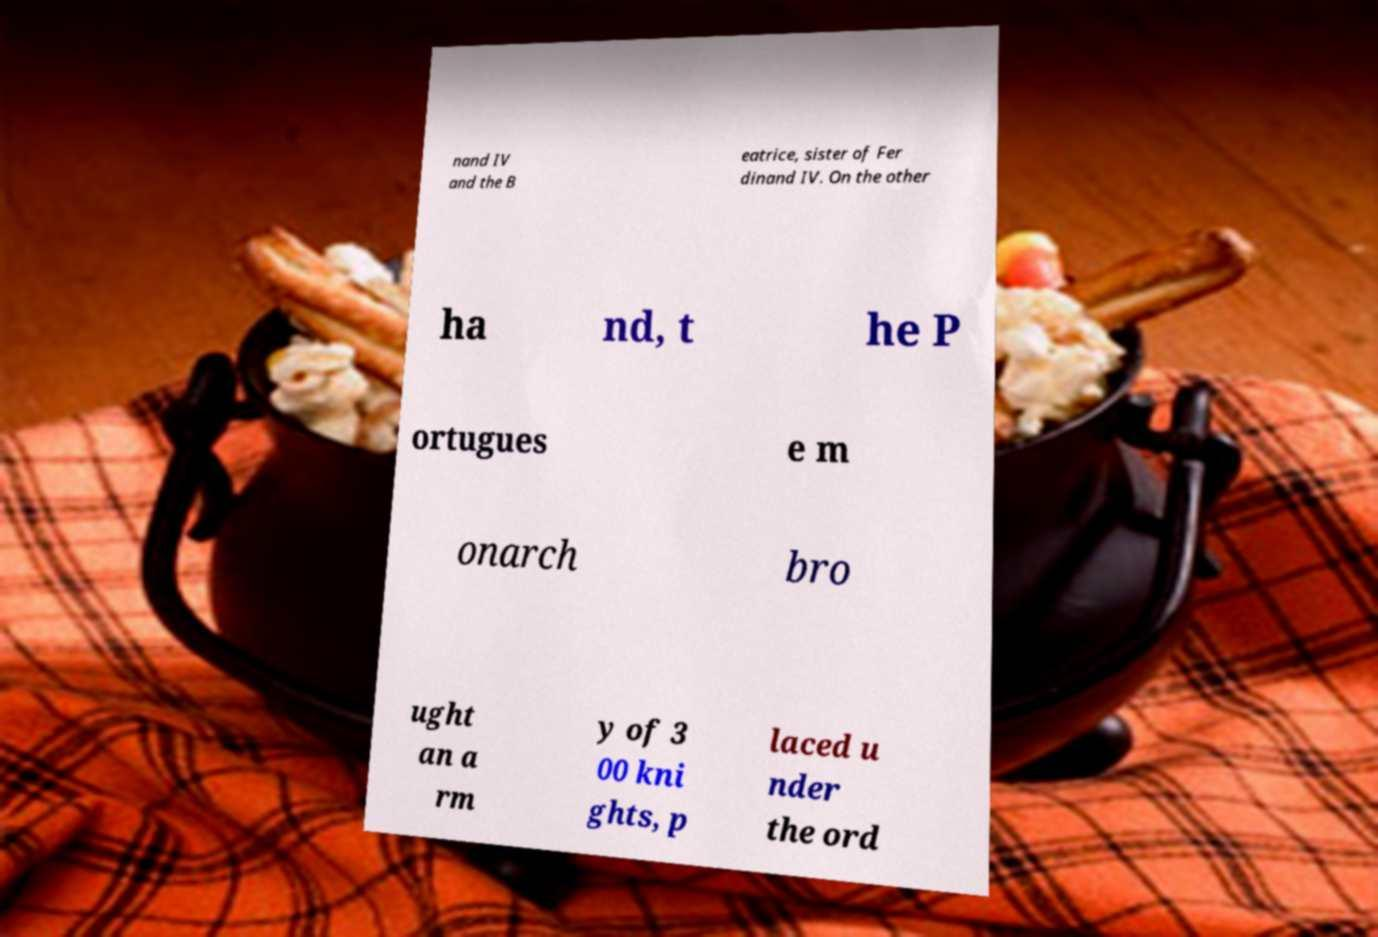There's text embedded in this image that I need extracted. Can you transcribe it verbatim? nand IV and the B eatrice, sister of Fer dinand IV. On the other ha nd, t he P ortugues e m onarch bro ught an a rm y of 3 00 kni ghts, p laced u nder the ord 